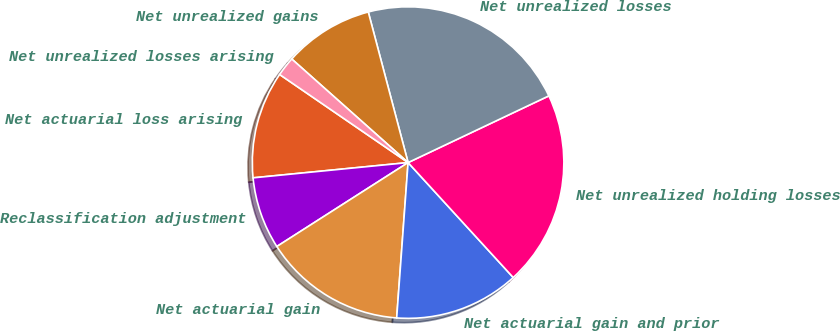Convert chart. <chart><loc_0><loc_0><loc_500><loc_500><pie_chart><fcel>Net actuarial loss arising<fcel>Reclassification adjustment<fcel>Net actuarial gain<fcel>Net actuarial gain and prior<fcel>Net unrealized holding losses<fcel>Net unrealized losses<fcel>Net unrealized gains<fcel>Net unrealized losses arising<nl><fcel>11.13%<fcel>7.49%<fcel>14.78%<fcel>12.96%<fcel>20.25%<fcel>22.07%<fcel>9.31%<fcel>2.01%<nl></chart> 